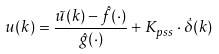Convert formula to latex. <formula><loc_0><loc_0><loc_500><loc_500>u ( k ) = \frac { \tilde { u } ( k ) - \hat { f } ( \cdot ) } { \hat { g } ( \cdot ) } + K _ { p s s } \cdot \dot { \delta } ( k )</formula> 